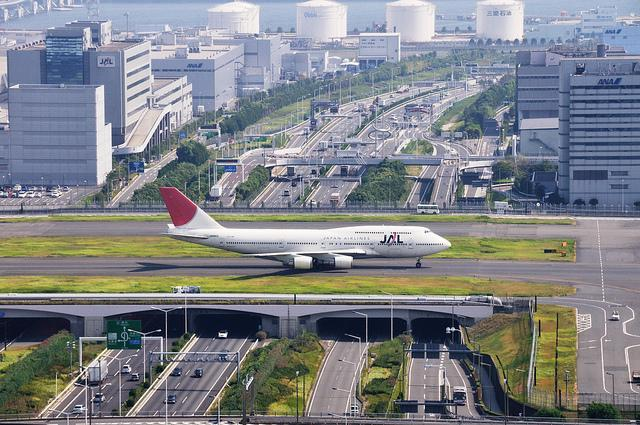What vehicle is the largest shown?

Choices:
A) airplane
B) buggy
C) tank
D) elephant airplane 